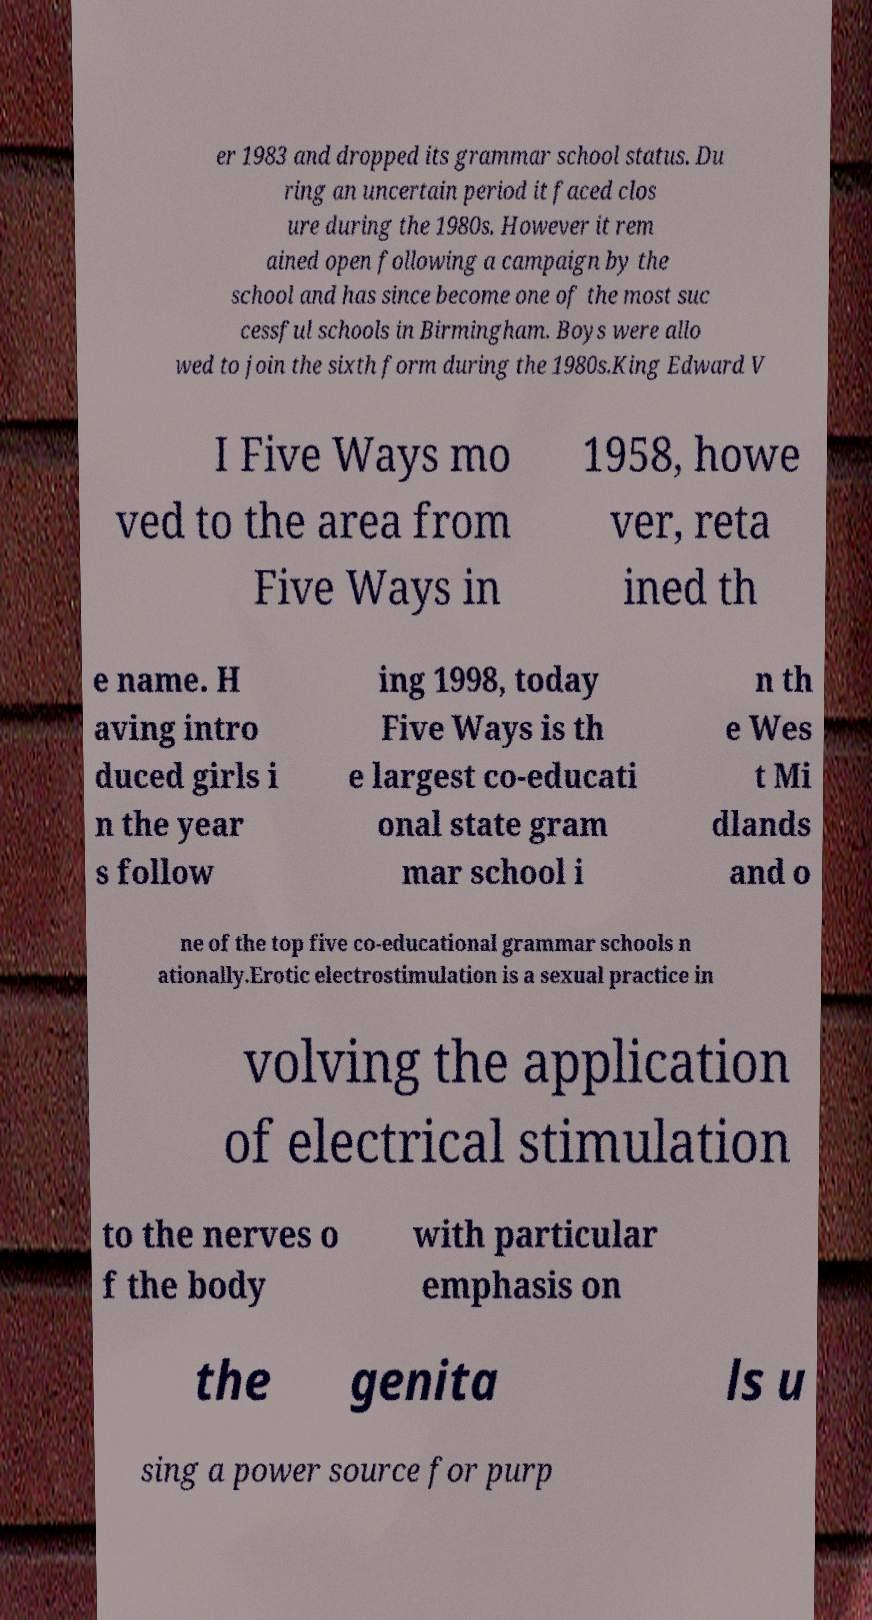Please identify and transcribe the text found in this image. er 1983 and dropped its grammar school status. Du ring an uncertain period it faced clos ure during the 1980s. However it rem ained open following a campaign by the school and has since become one of the most suc cessful schools in Birmingham. Boys were allo wed to join the sixth form during the 1980s.King Edward V I Five Ways mo ved to the area from Five Ways in 1958, howe ver, reta ined th e name. H aving intro duced girls i n the year s follow ing 1998, today Five Ways is th e largest co-educati onal state gram mar school i n th e Wes t Mi dlands and o ne of the top five co-educational grammar schools n ationally.Erotic electrostimulation is a sexual practice in volving the application of electrical stimulation to the nerves o f the body with particular emphasis on the genita ls u sing a power source for purp 